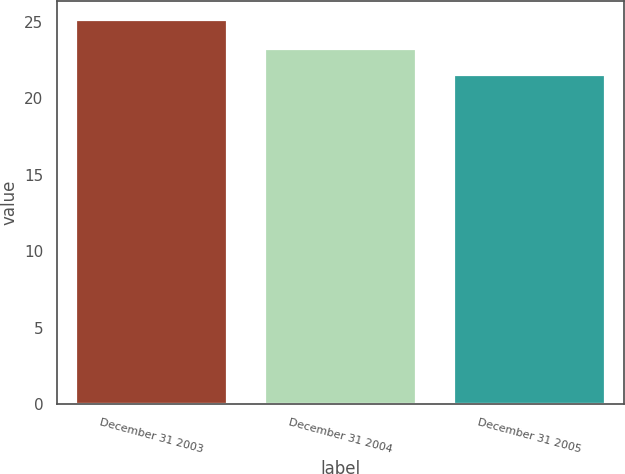Convert chart. <chart><loc_0><loc_0><loc_500><loc_500><bar_chart><fcel>December 31 2003<fcel>December 31 2004<fcel>December 31 2005<nl><fcel>25.1<fcel>23.2<fcel>21.5<nl></chart> 